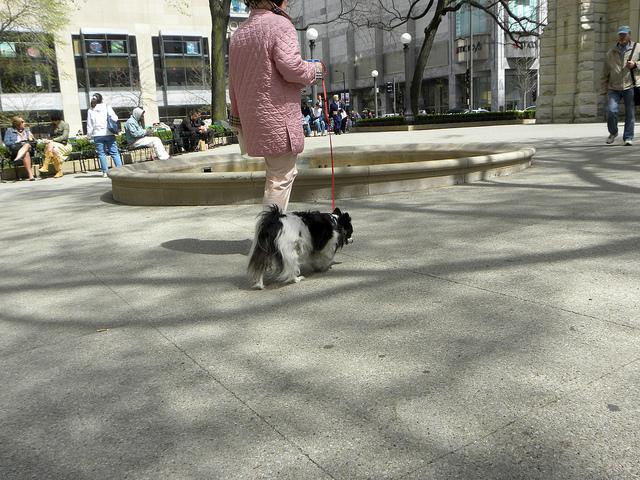How many people are visible?
Give a very brief answer. 2. How many boats are not on shore?
Give a very brief answer. 0. 